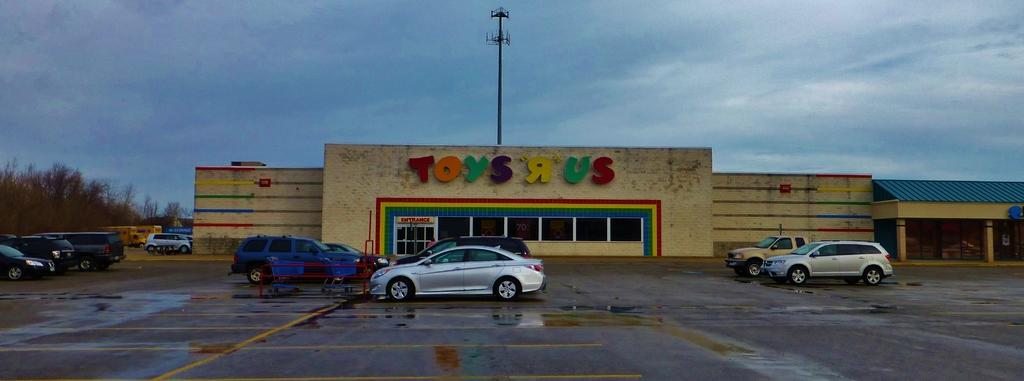What can be seen on the road in the image? There are vehicles on the road in the image. What else is present on the road besides vehicles? There is a stand on the road in the image. What can be seen in the background of the image? There are sheds, a tower, and trees visible in the background of the image. What is visible at the top of the image? The sky is visible at the top of the image, and there are clouds in the sky. Where are the straw and flowers located in the image? There is no straw or flowers present in the image. Can you tell me how many birds are in the flock in the image? There is no flock of birds present in the image. 